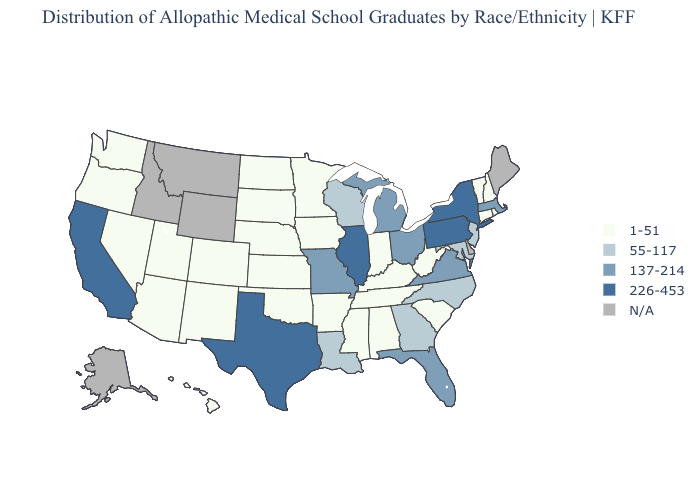Does California have the lowest value in the West?
Keep it brief. No. Does California have the lowest value in the West?
Write a very short answer. No. What is the highest value in the West ?
Short answer required. 226-453. What is the value of Alabama?
Answer briefly. 1-51. What is the value of Rhode Island?
Write a very short answer. 1-51. Which states have the lowest value in the USA?
Answer briefly. Alabama, Arizona, Arkansas, Colorado, Connecticut, Hawaii, Indiana, Iowa, Kansas, Kentucky, Minnesota, Mississippi, Nebraska, Nevada, New Hampshire, New Mexico, North Dakota, Oklahoma, Oregon, Rhode Island, South Carolina, South Dakota, Tennessee, Utah, Vermont, Washington, West Virginia. What is the value of Colorado?
Answer briefly. 1-51. What is the value of New Mexico?
Short answer required. 1-51. Does the first symbol in the legend represent the smallest category?
Concise answer only. Yes. What is the highest value in states that border Pennsylvania?
Be succinct. 226-453. What is the highest value in the USA?
Concise answer only. 226-453. Among the states that border Wisconsin , which have the lowest value?
Short answer required. Iowa, Minnesota. What is the value of Arizona?
Answer briefly. 1-51. Among the states that border Oklahoma , which have the highest value?
Keep it brief. Texas. What is the value of South Dakota?
Short answer required. 1-51. 